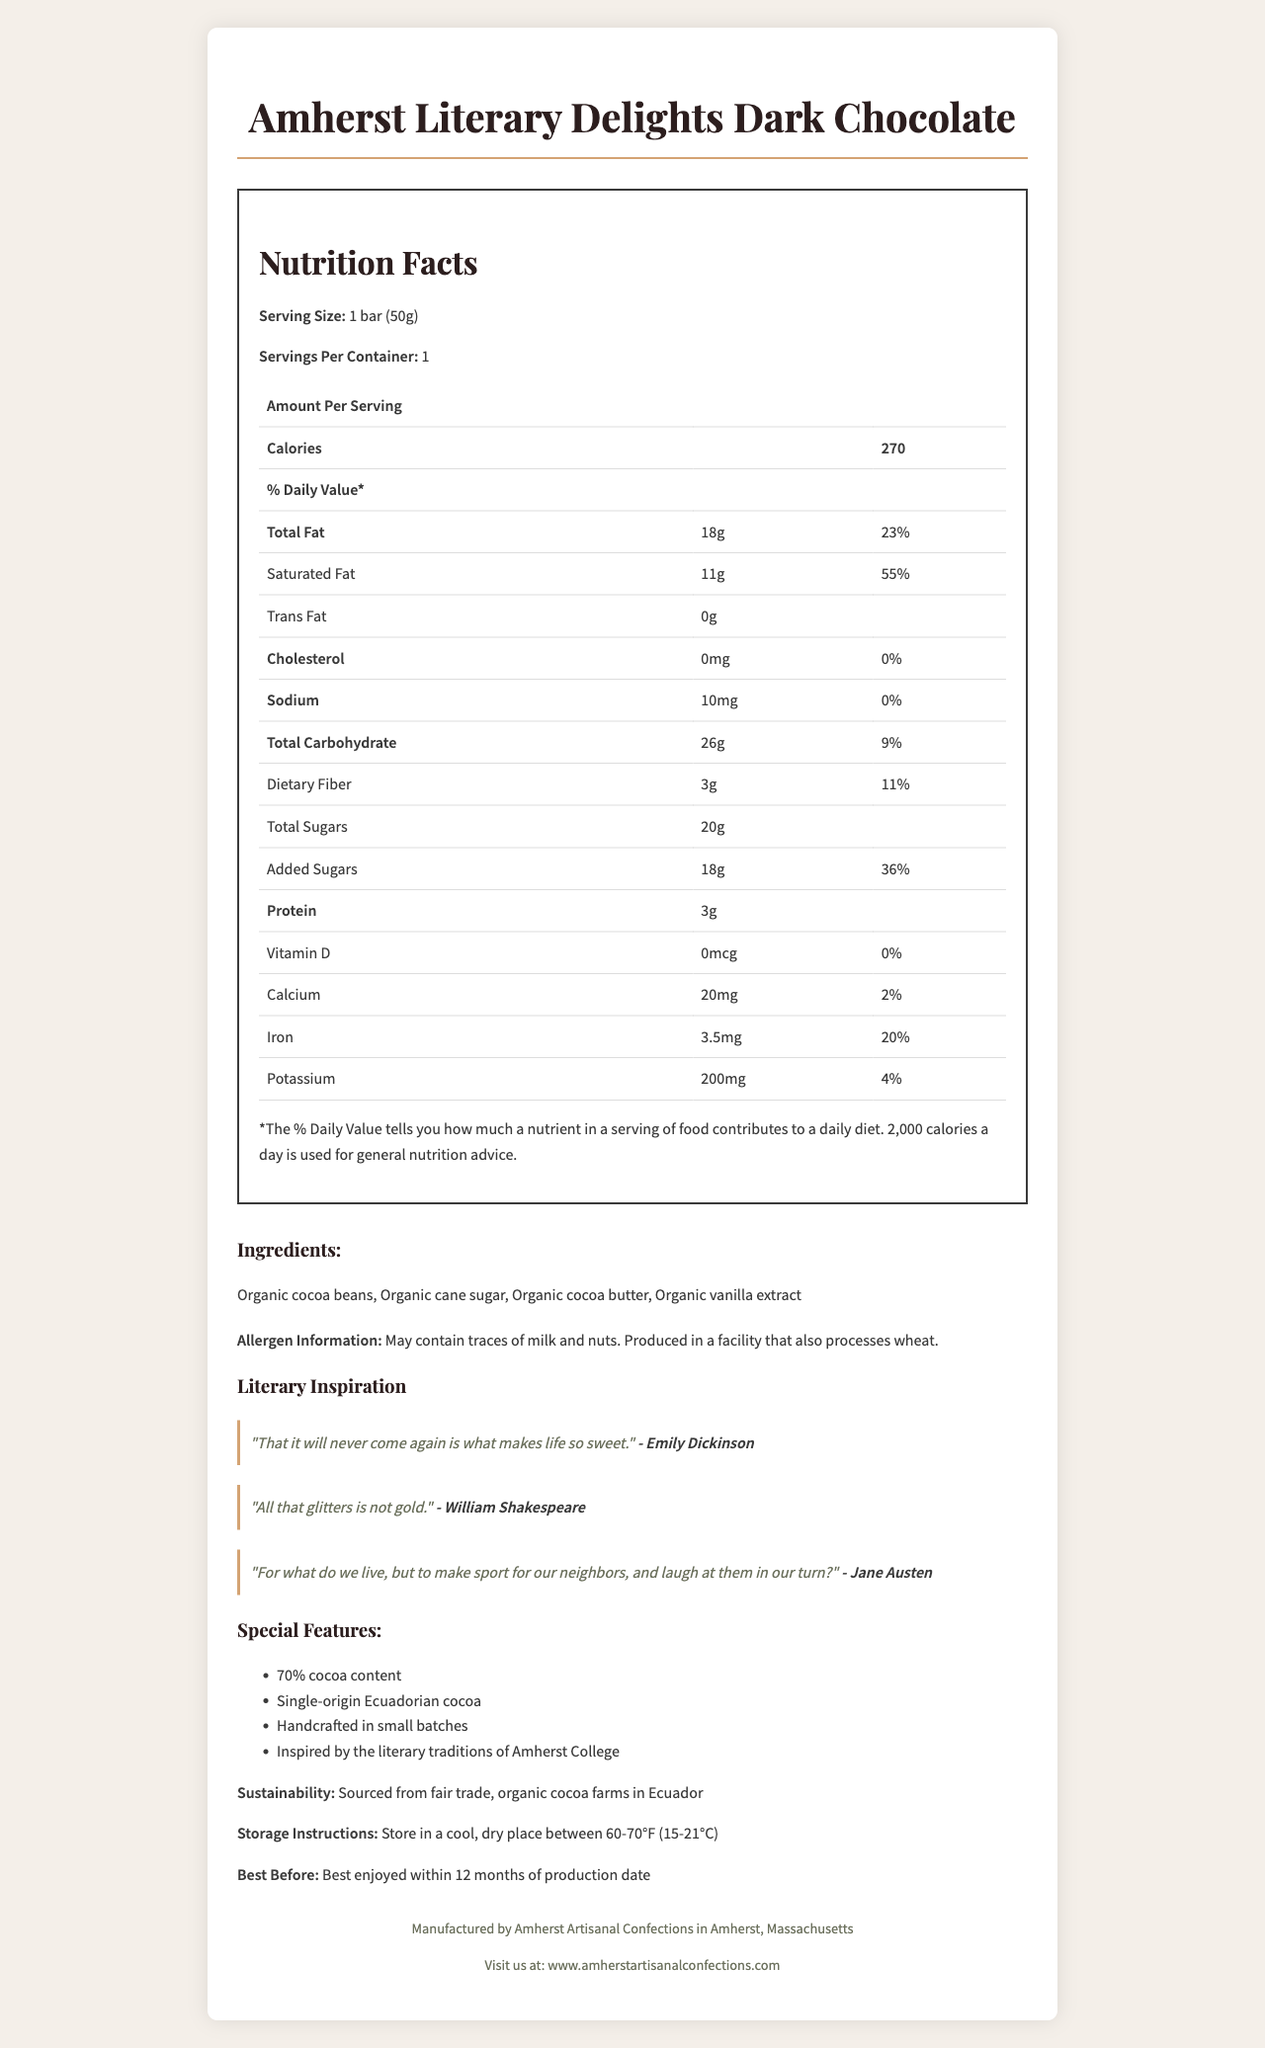how many calories are in one bar? The document lists 270 calories per serving, and the serving size is one bar (50g).
Answer: 270 calories what is the serving size of Amherst Literary Delights Dark Chocolate? The serving size information is given directly in the document as "1 bar (50g)."
Answer: 1 bar (50g) what is the primary source of dietary fiber in the chocolate bar? The document does not specify the individual contributions of ingredients to dietary fiber.
Answer: Cannot be determined what percentage of the daily value of saturated fat does one bar provide? The document states that one bar provides 11g of saturated fat, which is 55% of the daily value.
Answer: 55% which ingredient is used in the least amount based on the list provided? Ingredients are usually listed in order of quantity used from highest to lowest. Organic vanilla extract is the last listed ingredient.
Answer: Organic vanilla extract which of the following literary quotes is included on the packaging? A. "All that glitters is not gold." B. "To be or not to be." C. "It is a truth universally acknowledged, that a single man in possession of a good fortune, must be in want of a wife." The document includes three quotes, and "All that glitters is not gold" by William Shakespeare is one of them.
Answer: A how much protein does the chocolate bar contain? The document states that there are 3 grams of protein per serving, and one bar is one serving.
Answer: 3g what are the storage instructions for this chocolate? The storage instructions in the document specifically mention to store the chocolate in a cool, dry place between 60-70°F (15-21°C).
Answer: Store in a cool, dry place between 60-70°F (15-21°C) does the chocolate bar contain any cholesterol? The document lists 0mg of cholesterol in the chocolate bar.
Answer: No who manufactures Amherst Literary Delights Dark Chocolate? The document specifies that the manufacturer is Amherst Artisanal Confections.
Answer: Amherst Artisanal Confections describe the main idea of the document. The document contains comprehensive information about the chocolate bar, including its nutritional profile, ingredient list, manufacturing details, and literary inspirations, to give consumers a full understanding of the product.
Answer: The document is an informative overview of Amherst Literary Delights Dark Chocolate; it includes details about the product's nutrition facts, ingredients, allergen information, sustainability, special features, literary quotes, and storage instructions. can you tell me the exact production date of this chocolate bar? The document provides a general expiration date ("Best enjoyed within 12 months of production date"), but does not list the exact production date.
Answer: Not enough information 